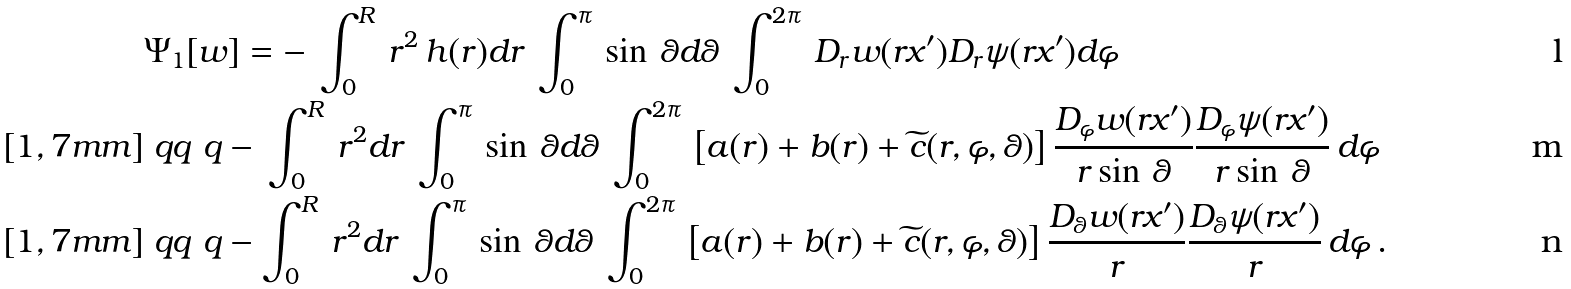<formula> <loc_0><loc_0><loc_500><loc_500>& { \Psi } _ { 1 } [ w ] = - \, \int _ { 0 } ^ { R } \, r ^ { 2 } \, { h } ( r ) d r \, \int _ { 0 } ^ { \pi } \, \sin \, \theta d \theta \, \int _ { 0 } ^ { 2 \pi } \, D _ { r } w ( r x ^ { \prime } ) D _ { r } \psi ( r x ^ { \prime } ) d \varphi & \\ [ 1 , 7 m m ] & \ q q \ q - \, \int _ { 0 } ^ { R } \, r ^ { 2 } d r \, \int _ { 0 } ^ { \pi } \, \sin \, \theta d \theta \, \int _ { 0 } ^ { 2 \pi } \, \left [ { a } ( r ) + { b } ( r ) + \widetilde { c } ( r , \varphi , \theta ) \right ] \frac { D _ { \varphi } w ( r x ^ { \prime } ) } { r \sin \, \theta } \frac { D _ { \varphi } \psi ( r x ^ { \prime } ) } { r \sin \, \theta } \, d \varphi & \\ [ 1 , 7 m m ] & \ q q \ q - \int _ { 0 } ^ { R } \, r ^ { 2 } d r \, \int _ { 0 } ^ { \pi } \, \sin \, \theta d \theta \, \int _ { 0 } ^ { 2 \pi } \, \left [ { a } ( r ) + { b } ( r ) + \widetilde { c } ( r , \varphi , \theta ) \right ] \frac { { D _ { \theta } w ( r x ^ { \prime } ) } } { r } \frac { D _ { \theta } \psi ( r x ^ { \prime } ) } { r } \, d \varphi \, . &</formula> 